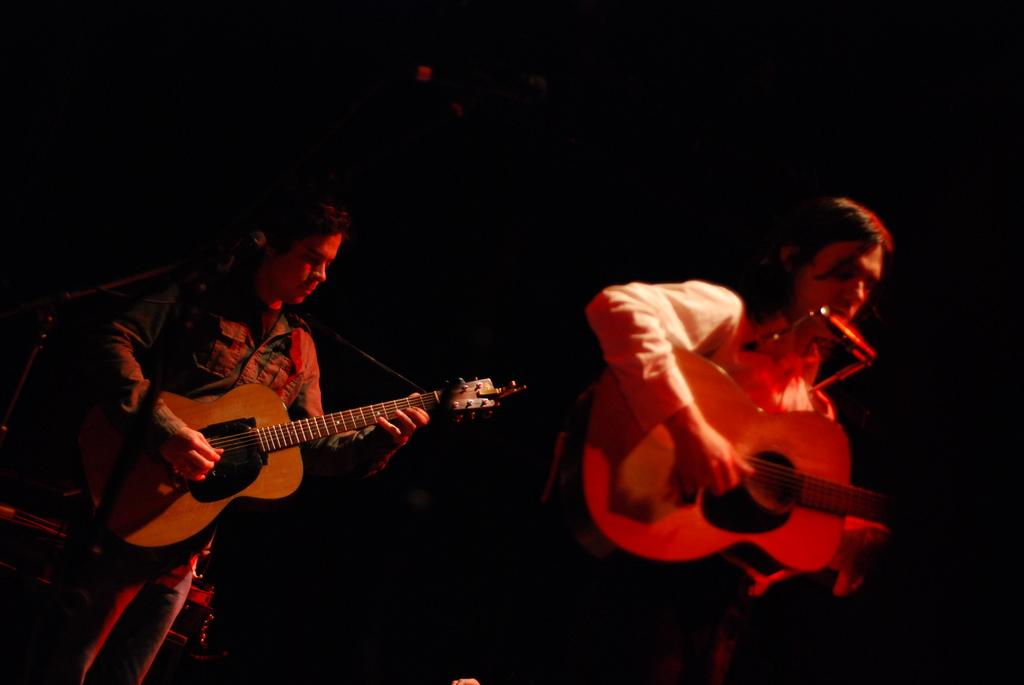How many people are in the image? There are two people in the image. What are the two people doing in the image? The two people are standing in the image. What objects are the two people holding? The two people are holding guitars in the image. What type of idea is being written down in a notebook in the image? There is no notebook or idea present in the image; it features two people holding guitars. Where is the hospital located in the image? There is no hospital present in the image. 